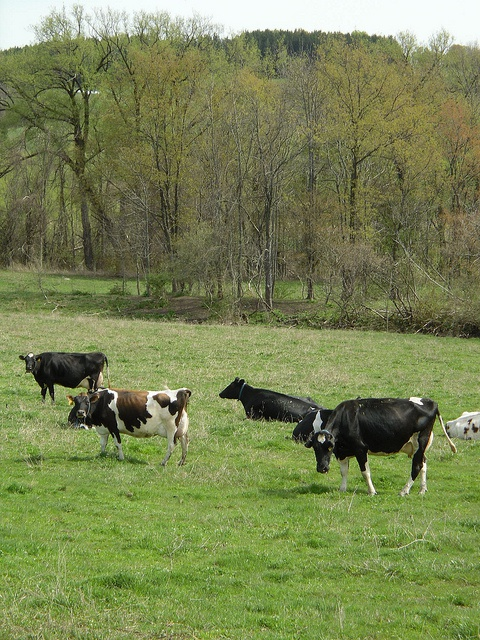Describe the objects in this image and their specific colors. I can see cow in white, black, gray, darkgreen, and olive tones, cow in white, black, olive, gray, and darkgray tones, cow in white, black, gray, olive, and darkgreen tones, cow in white, black, gray, darkgreen, and olive tones, and cow in white, black, darkgray, gray, and darkgreen tones in this image. 